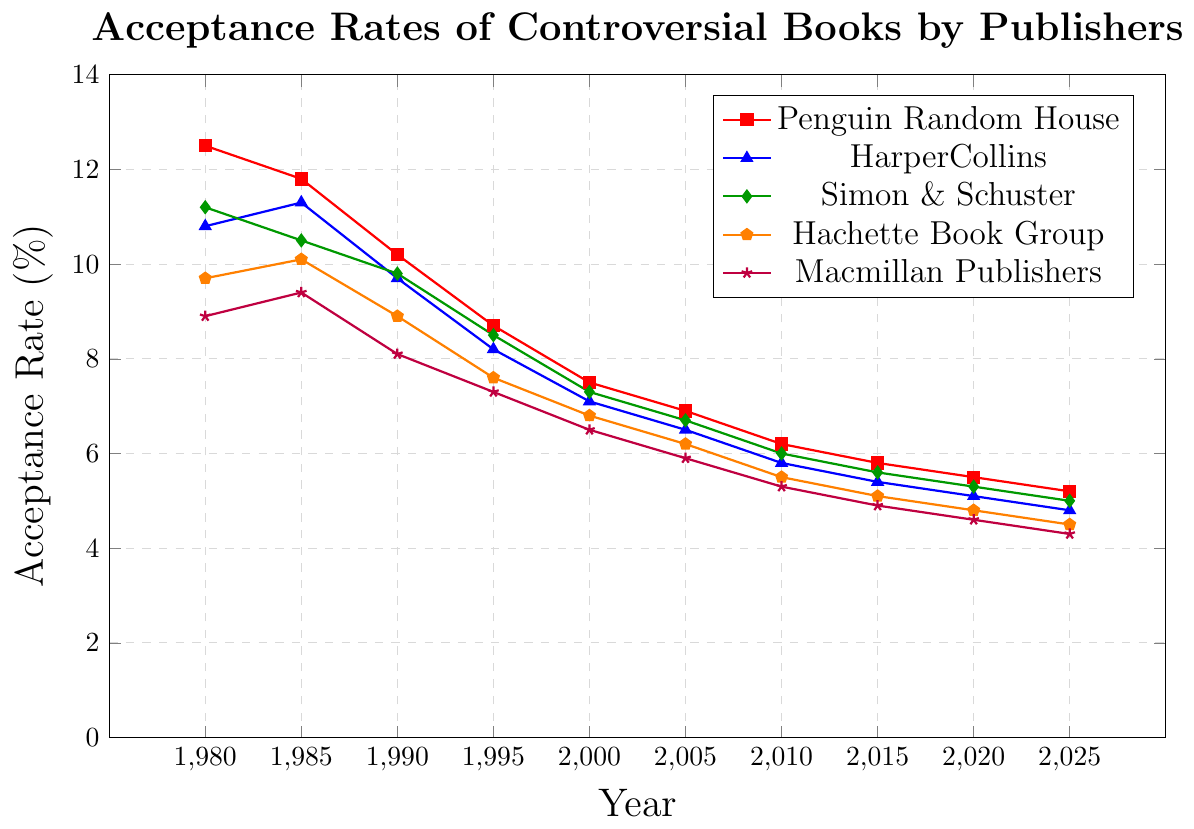Which publisher had the highest acceptance rate of controversial books in 1980? Examine the values for each publisher in the year 1980. Penguin Random House had the highest acceptance rate at 12.5%.
Answer: Penguin Random House By how much did the acceptance rate of Penguin Random House decrease from 1980 to 2025? Subtract the acceptance rate of Penguin Random House in 2025 (5.2) from its rate in 1980 (12.5): 12.5 - 5.2 = 7.3%.
Answer: 7.3% Which publisher experienced the smallest decrease in acceptance rates from 1980 to 2025? Calculate the difference for each publisher between 1980 and 2025, then compare the differences. Penguin Random House: 12.5 - 5.2 = 7.3, HarperCollins: 10.8 - 4.8 = 6.0, Simon & Schuster: 11.2 - 5.0 = 6.2, Hachette Book Group: 9.7 - 4.5 = 5.2, Macmillan Publishers: 8.9 - 4.3 = 4.6. The smallest decrease is for Macmillan Publishers with 4.6%.
Answer: Macmillan Publishers What is the overall trend in acceptance rates for controversial books by mainstream publishers from 1980 to 2025? Observe the general direction of the lines for each publisher from 1980 to 2025. All lines are trending downward, indicating a decrease in acceptance rates.
Answer: Decreasing Which two publishers had the closest acceptance rates in the year 2020? Compare the values for each publisher in 2020. Hachette Book Group (4.8%) and Macmillan Publishers (4.6%) had the closest acceptance rates.
Answer: Hachette Book Group and Macmillan Publishers What is the average acceptance rate of HarperCollins over the given time period? Sum the acceptance rates of HarperCollins for each year and divide by the number of years: (10.8 + 11.3 + 9.7 + 8.2 + 7.1 + 6.5 + 5.8 + 5.4 + 5.1 + 4.8) / 10 = 7.47%.
Answer: 7.47% In which year did Simon & Schuster have an acceptance rate of 9.8%? Look at the data points for Simon & Schuster and find the year corresponding to 9.8%. This occurs in 1990.
Answer: 1990 Which publisher consistently had the lowest acceptance rate from 2005 onwards? Compare the acceptance rates of each publisher from 2005 to 2025. Macmillan Publishers consistently had the lowest rates.
Answer: Macmillan Publishers What was the difference in acceptance rates between HarperCollins and Penguin Random House in 1985? Subtract the acceptance rate of HarperCollins (11.3) from that of Penguin Random House (11.8): 11.8 - 11.3 = 0.5%.
Answer: 0.5% What can be inferred about the overall trend of mainstream publishers' tolerance for controversial books from 1980 to 2025? By analyzing the downward trends of the acceptance rates for all publishers over the years, it implies that mainstream publishers have become less tolerant of controversial books over time.
Answer: Less tolerant 